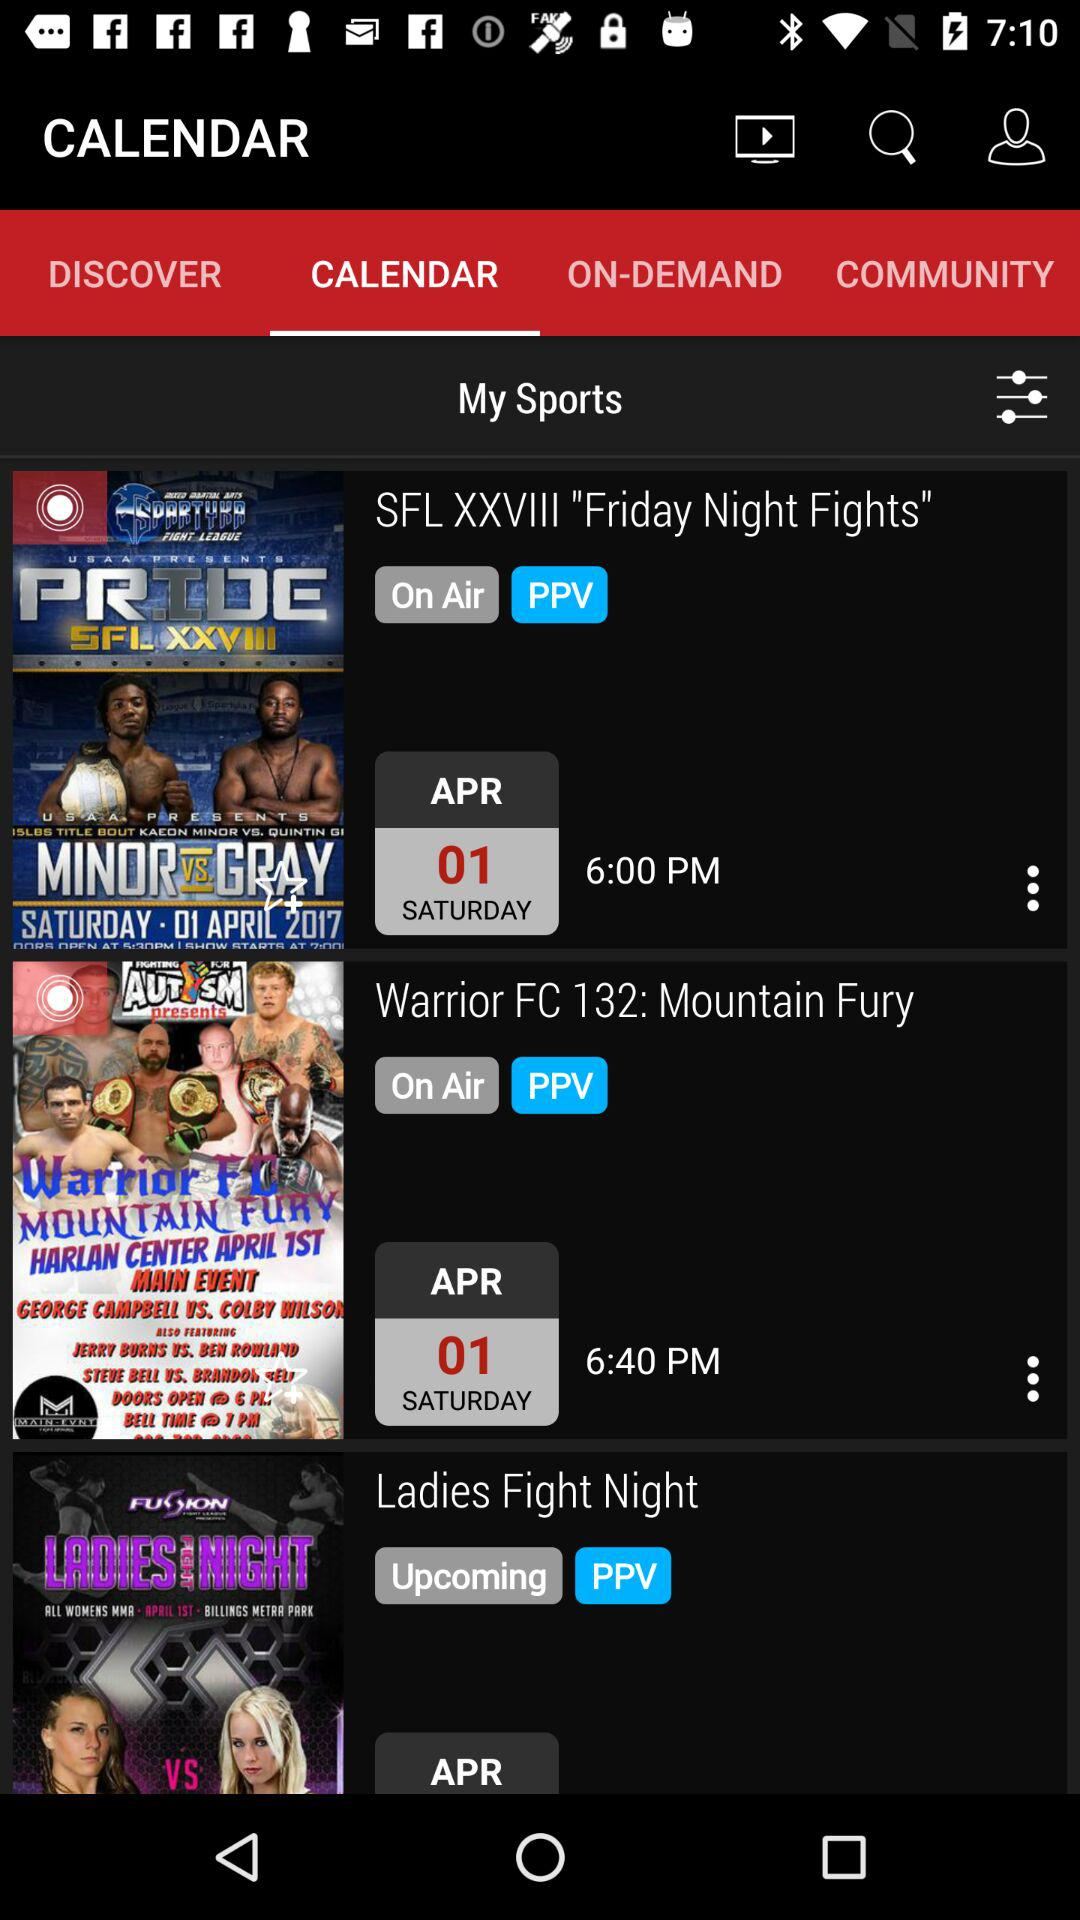Which is the upcoming show? The upcoming show is "Ladies Fight Night". 